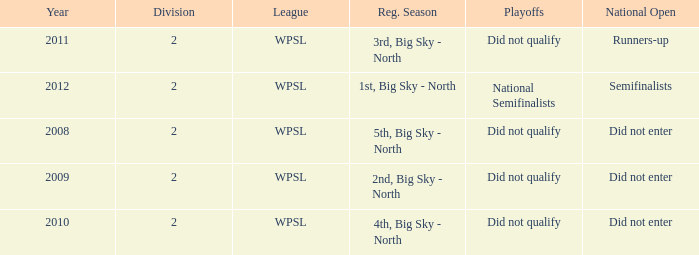What was the regular season name where they did not qualify for the playoffs in 2009? 2nd, Big Sky - North. 